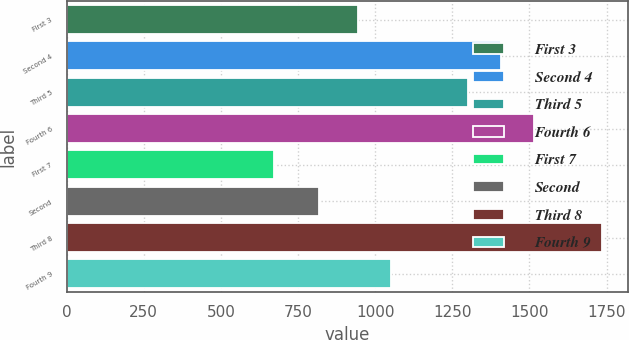Convert chart. <chart><loc_0><loc_0><loc_500><loc_500><bar_chart><fcel>First 3<fcel>Second 4<fcel>Third 5<fcel>Fourth 6<fcel>First 7<fcel>Second<fcel>Third 8<fcel>Fourth 9<nl><fcel>944<fcel>1407.2<fcel>1301<fcel>1513.4<fcel>672<fcel>818<fcel>1734<fcel>1050.2<nl></chart> 